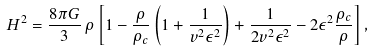Convert formula to latex. <formula><loc_0><loc_0><loc_500><loc_500>H ^ { 2 } & = \frac { 8 \pi G } { 3 } \, \rho \left [ 1 - \frac { \rho } { \rho _ { c } } \left ( 1 + \frac { 1 } { v ^ { 2 } \epsilon ^ { 2 } } \right ) + \frac { 1 } { 2 v ^ { 2 } \epsilon ^ { 2 } } - 2 \epsilon ^ { 2 } \frac { \rho _ { c } } { \rho } \right ] ,</formula> 